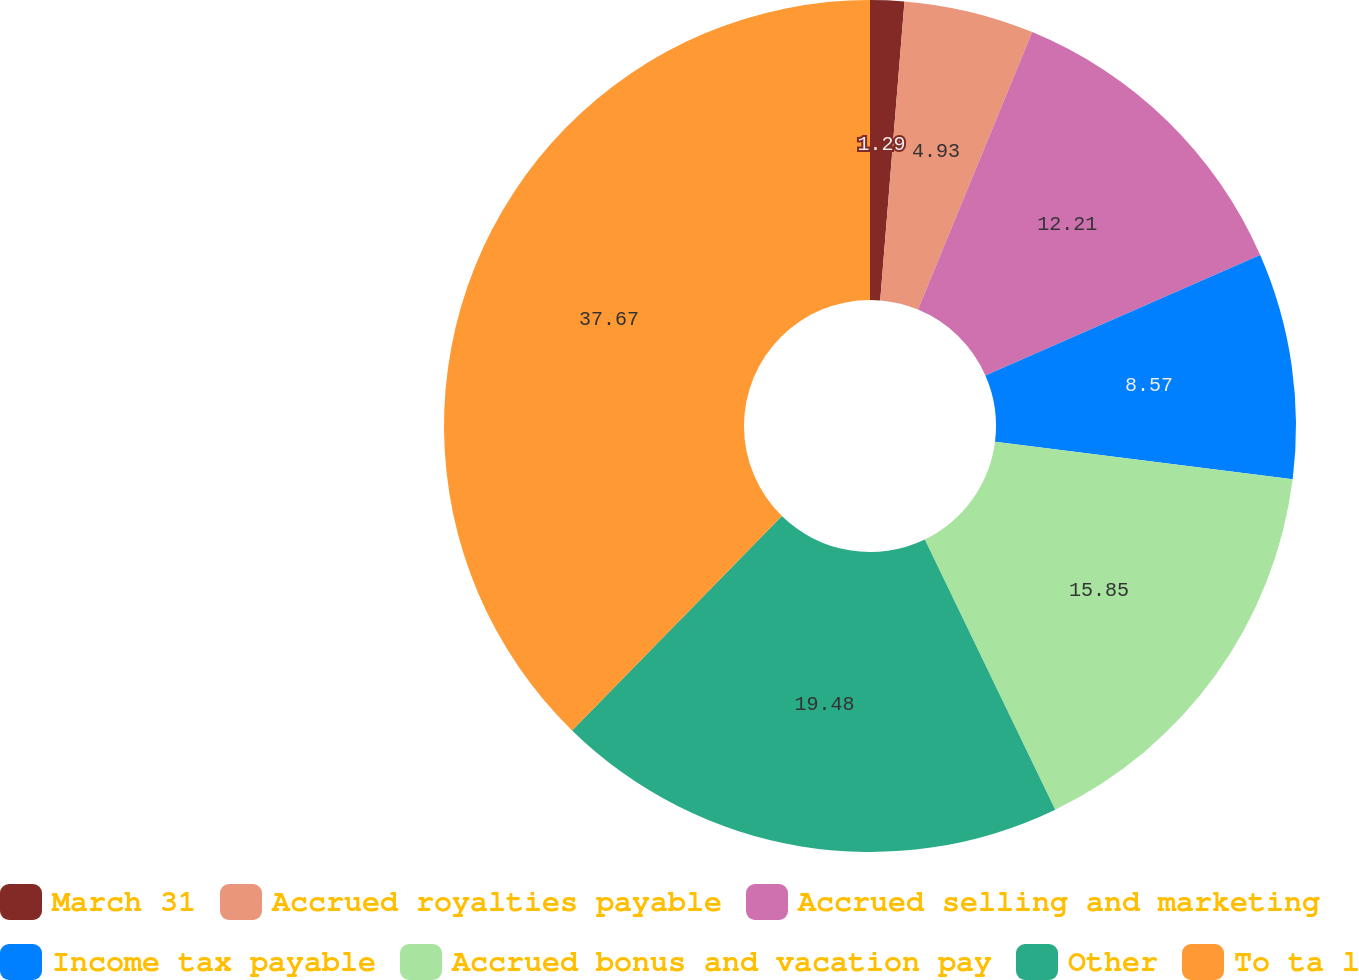<chart> <loc_0><loc_0><loc_500><loc_500><pie_chart><fcel>March 31<fcel>Accrued royalties payable<fcel>Accrued selling and marketing<fcel>Income tax payable<fcel>Accrued bonus and vacation pay<fcel>Other<fcel>To ta l<nl><fcel>1.29%<fcel>4.93%<fcel>12.21%<fcel>8.57%<fcel>15.85%<fcel>19.49%<fcel>37.68%<nl></chart> 